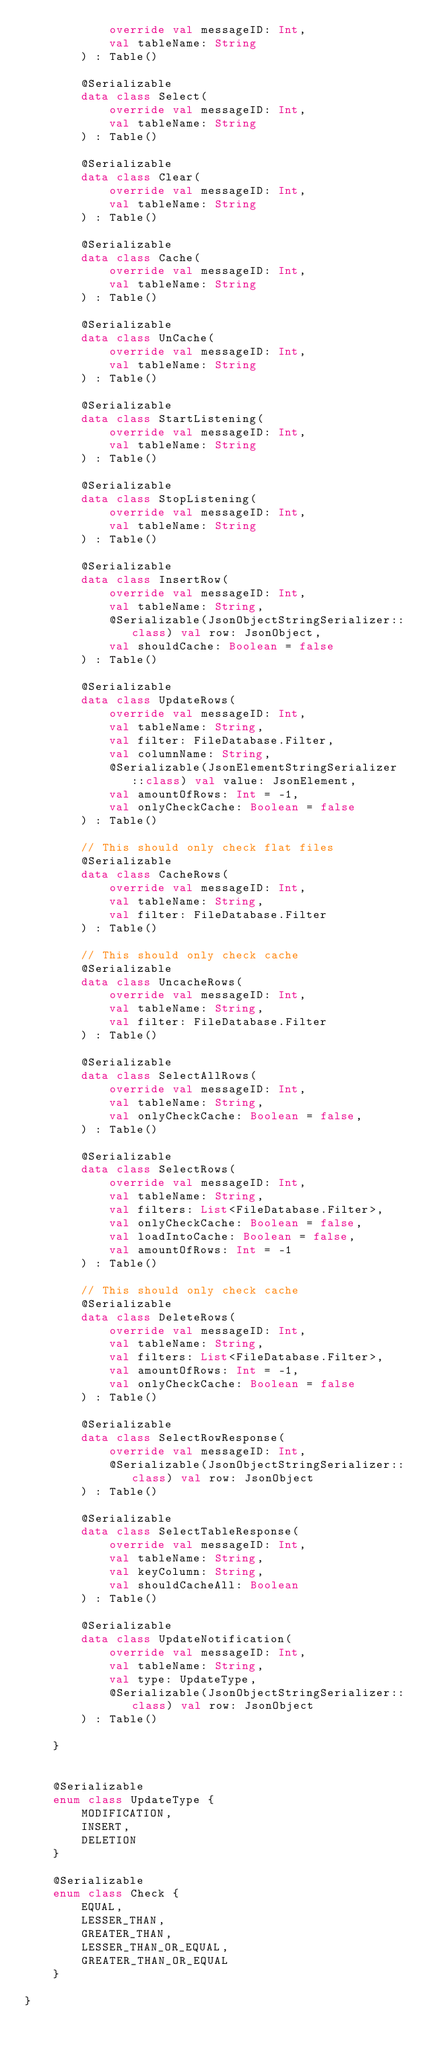Convert code to text. <code><loc_0><loc_0><loc_500><loc_500><_Kotlin_>            override val messageID: Int,
            val tableName: String
        ) : Table()

        @Serializable
        data class Select(
            override val messageID: Int,
            val tableName: String
        ) : Table()

        @Serializable
        data class Clear(
            override val messageID: Int,
            val tableName: String
        ) : Table()

        @Serializable
        data class Cache(
            override val messageID: Int,
            val tableName: String
        ) : Table()

        @Serializable
        data class UnCache(
            override val messageID: Int,
            val tableName: String
        ) : Table()

        @Serializable
        data class StartListening(
            override val messageID: Int,
            val tableName: String
        ) : Table()

        @Serializable
        data class StopListening(
            override val messageID: Int,
            val tableName: String
        ) : Table()

        @Serializable
        data class InsertRow(
            override val messageID: Int,
            val tableName: String,
            @Serializable(JsonObjectStringSerializer::class) val row: JsonObject,
            val shouldCache: Boolean = false
        ) : Table()

        @Serializable
        data class UpdateRows(
            override val messageID: Int,
            val tableName: String,
            val filter: FileDatabase.Filter,
            val columnName: String,
            @Serializable(JsonElementStringSerializer::class) val value: JsonElement,
            val amountOfRows: Int = -1,
            val onlyCheckCache: Boolean = false
        ) : Table()

        // This should only check flat files
        @Serializable
        data class CacheRows(
            override val messageID: Int,
            val tableName: String,
            val filter: FileDatabase.Filter
        ) : Table()

        // This should only check cache
        @Serializable
        data class UncacheRows(
            override val messageID: Int,
            val tableName: String,
            val filter: FileDatabase.Filter
        ) : Table()

        @Serializable
        data class SelectAllRows(
            override val messageID: Int,
            val tableName: String,
            val onlyCheckCache: Boolean = false,
        ) : Table()

        @Serializable
        data class SelectRows(
            override val messageID: Int,
            val tableName: String,
            val filters: List<FileDatabase.Filter>,
            val onlyCheckCache: Boolean = false,
            val loadIntoCache: Boolean = false,
            val amountOfRows: Int = -1
        ) : Table()

        // This should only check cache
        @Serializable
        data class DeleteRows(
            override val messageID: Int,
            val tableName: String,
            val filters: List<FileDatabase.Filter>,
            val amountOfRows: Int = -1,
            val onlyCheckCache: Boolean = false
        ) : Table()

        @Serializable
        data class SelectRowResponse(
            override val messageID: Int,
            @Serializable(JsonObjectStringSerializer::class) val row: JsonObject
        ) : Table()

        @Serializable
        data class SelectTableResponse(
            override val messageID: Int,
            val tableName: String,
            val keyColumn: String,
            val shouldCacheAll: Boolean
        ) : Table()

        @Serializable
        data class UpdateNotification(
            override val messageID: Int,
            val tableName: String,
            val type: UpdateType,
            @Serializable(JsonObjectStringSerializer::class) val row: JsonObject
        ) : Table()

    }


    @Serializable
    enum class UpdateType {
        MODIFICATION,
        INSERT,
        DELETION
    }

    @Serializable
    enum class Check {
        EQUAL,
        LESSER_THAN,
        GREATER_THAN,
        LESSER_THAN_OR_EQUAL,
        GREATER_THAN_OR_EQUAL
    }

}</code> 